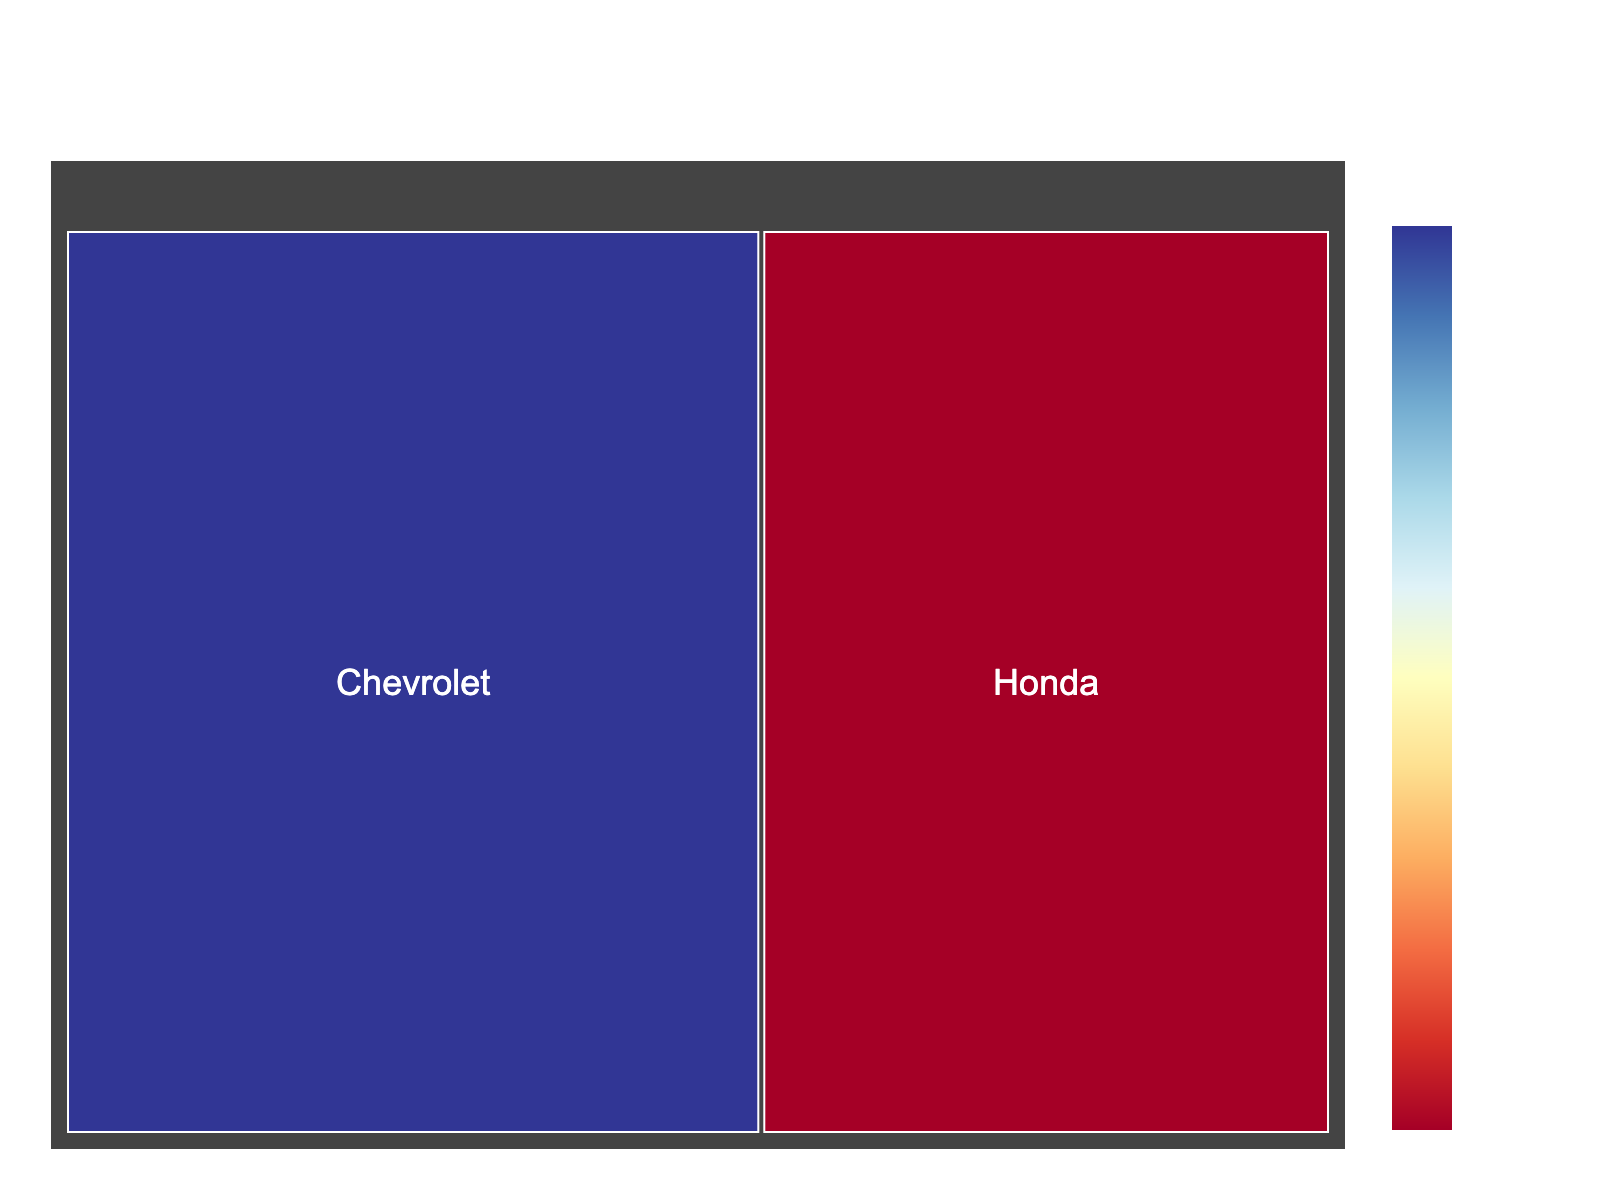What's the title of the treemap? The title is located at the top center of the figure and it specifies what the treemap represents.
Answer: IndyCar Engine Types Distribution What are the labels on the treemap? The labels represent the different engine types used in IndyCar racing and are located within the colored sections of the treemap.
Answer: Honda, Chevrolet What percentage of IndyCar engines are Honda? The percentage is shown within the section labeled "Honda" in the treemap.
Answer: 45% What percentage of IndyCar engines are Chevrolet? The percentage is shown within the section labeled "Chevrolet" in the treemap.
Answer: 55% Which engine type is more prevalent in IndyCar racing? By comparing the sizes and percentages of the sections labeled "Honda" and "Chevrolet" in the treemap, we can determine the more prevalent engine type.
Answer: Chevrolet What's the difference in percentage between Honda and Chevrolet engines? By subtracting the percentage of Honda engines from the percentage of Chevrolet engines (55% - 45%), we find the difference.
Answer: 10% What does the color intensity represent in the treemap? The color intensity of the sections corresponds to the percentage value, as indicated by the color axis color bar titled "Percentage."
Answer: Percentage Which engine type has the highest percentage? By looking at the colored sections and their associated percentages, we can identify that the section with the highest value is "Chevrolet."
Answer: Chevrolet If there were 100 cars, how many would be using Chevrolet engines? Given that 55% of the engines are Chevrolet, the calculation would be 55% of 100 cars, which equals 55 cars.
Answer: 55 If another engine type with 5% were added, how would the percentages of Honda and Chevrolet adjust? Adding a new engine type with 5% would reduce the existing percentages proportionally. Honda and Chevrolet would now sum to 95%. Thus, Honda would be approximately 42.11% and Chevrolet approximately 52.63% (calculated as 45/95 and 55/95 respectively, then multiplied by 100).
Answer: Honda: ~42.11%, Chevrolet: ~52.63% 